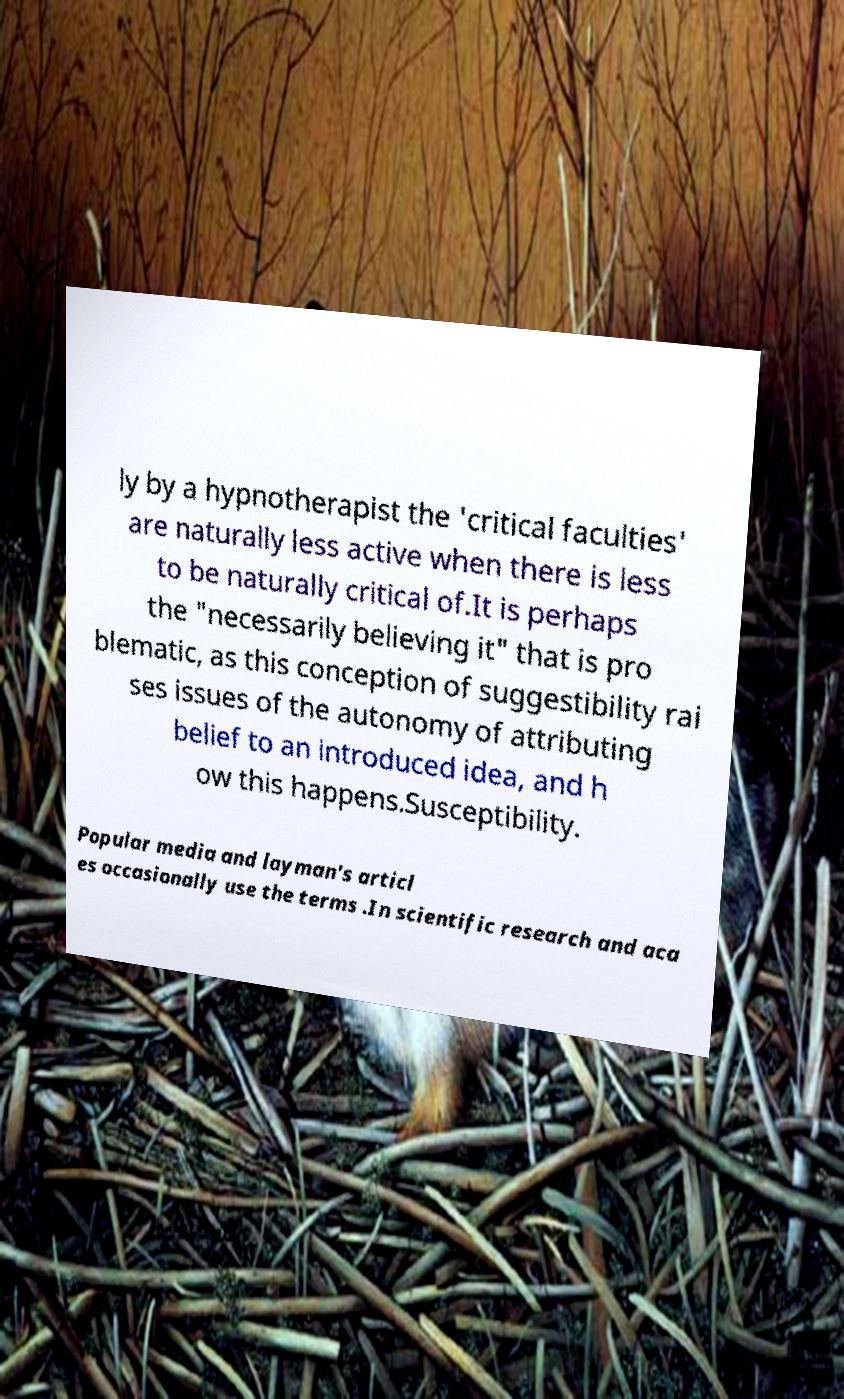Can you accurately transcribe the text from the provided image for me? ly by a hypnotherapist the 'critical faculties' are naturally less active when there is less to be naturally critical of.It is perhaps the "necessarily believing it" that is pro blematic, as this conception of suggestibility rai ses issues of the autonomy of attributing belief to an introduced idea, and h ow this happens.Susceptibility. Popular media and layman's articl es occasionally use the terms .In scientific research and aca 